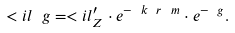<formula> <loc_0><loc_0><loc_500><loc_500>< i l _ { \ } g = < i l _ { Z } ^ { \prime } \cdot e ^ { - \ k \ r ^ { \ } m } \cdot e ^ { - \ g } .</formula> 